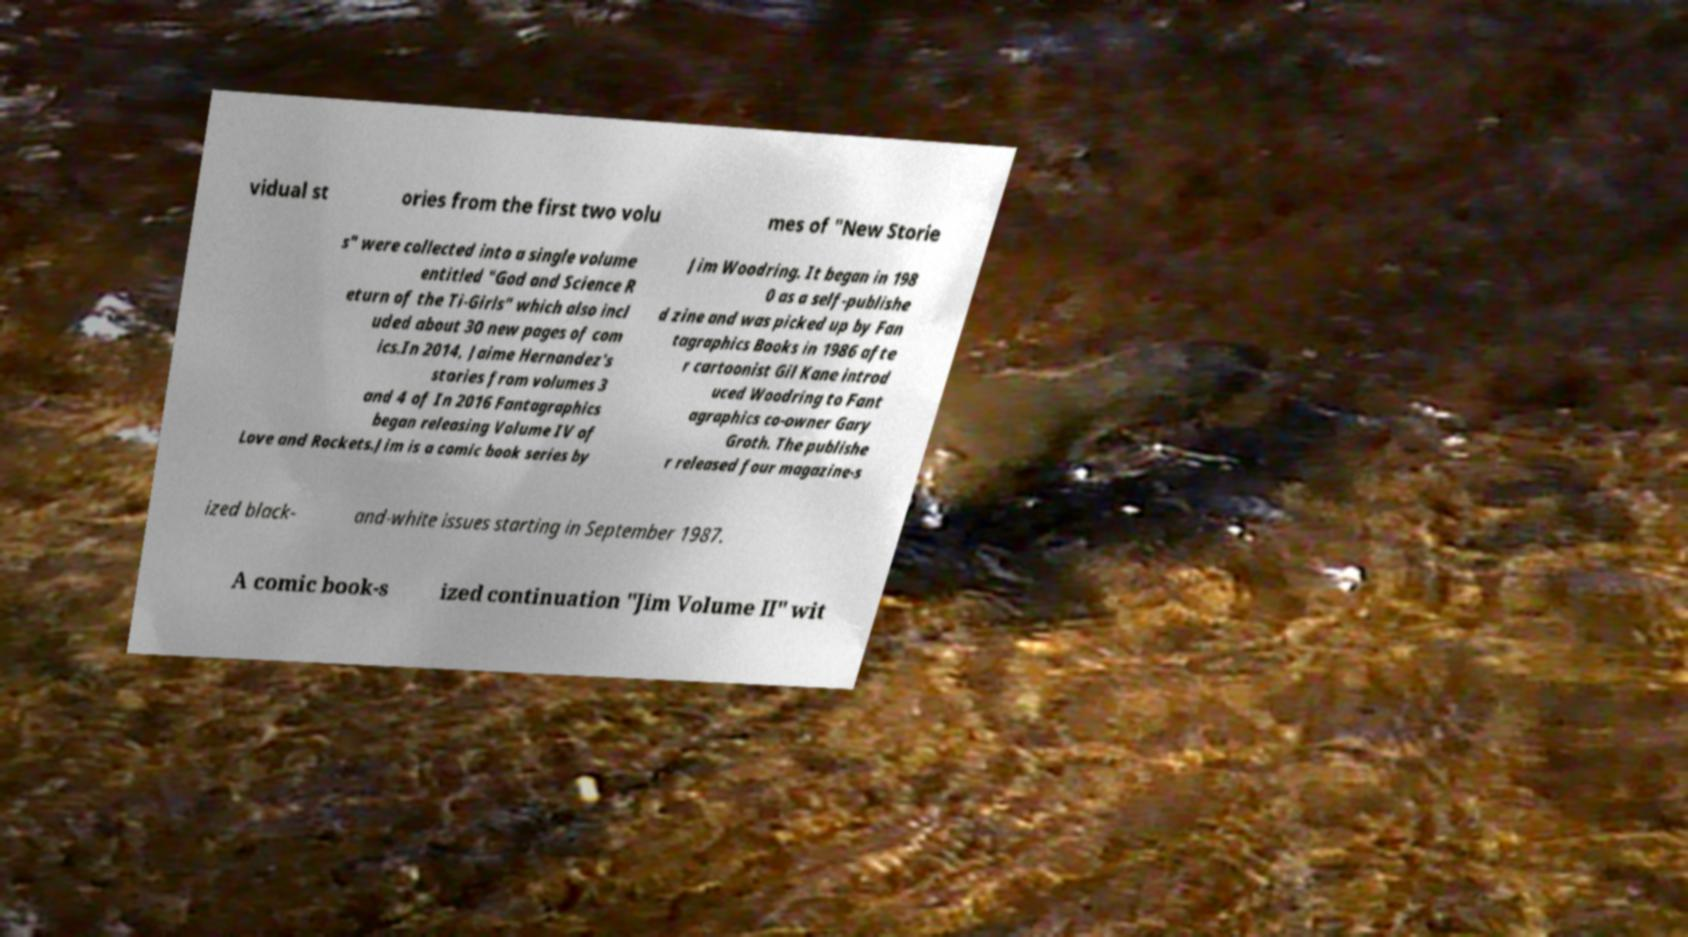Can you read and provide the text displayed in the image?This photo seems to have some interesting text. Can you extract and type it out for me? vidual st ories from the first two volu mes of "New Storie s" were collected into a single volume entitled "God and Science R eturn of the Ti-Girls" which also incl uded about 30 new pages of com ics.In 2014, Jaime Hernandez's stories from volumes 3 and 4 of In 2016 Fantagraphics began releasing Volume IV of Love and Rockets.Jim is a comic book series by Jim Woodring. It began in 198 0 as a self-publishe d zine and was picked up by Fan tagraphics Books in 1986 afte r cartoonist Gil Kane introd uced Woodring to Fant agraphics co-owner Gary Groth. The publishe r released four magazine-s ized black- and-white issues starting in September 1987. A comic book-s ized continuation "Jim Volume II" wit 